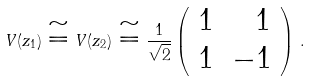Convert formula to latex. <formula><loc_0><loc_0><loc_500><loc_500>V ( z _ { 1 } ) \cong V ( z _ { 2 } ) \cong \frac { 1 } { \sqrt { 2 } } \left ( \begin{array} { r r } 1 & 1 \\ 1 & - 1 \end{array} \right ) \, .</formula> 